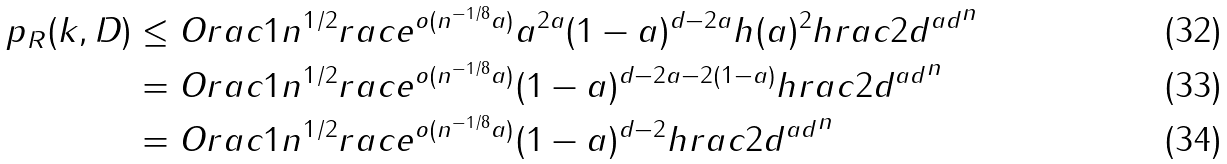<formula> <loc_0><loc_0><loc_500><loc_500>\ p _ { R } ( k , D ) & \leq O r a c { 1 } { n ^ { 1 / 2 } } r a c { e ^ { o ( n ^ { - 1 / 8 } a ) } a ^ { 2 a } ( 1 - a ) ^ { d - 2 a } } { h ( a ) ^ { 2 } h r a c { 2 } { d } ^ { a d } } ^ { n } \\ & = O r a c { 1 } { n ^ { 1 / 2 } } r a c { e ^ { o ( n ^ { - 1 / 8 } a ) } ( 1 - a ) ^ { d - 2 a - 2 ( 1 - a ) } } { h r a c { 2 } { d } ^ { a d } } ^ { n } \\ & = O r a c { 1 } { n ^ { 1 / 2 } } r a c { e ^ { o ( n ^ { - 1 / 8 } a ) } ( 1 - a ) ^ { d - 2 } } { h r a c { 2 } { d } ^ { a d } } ^ { n }</formula> 